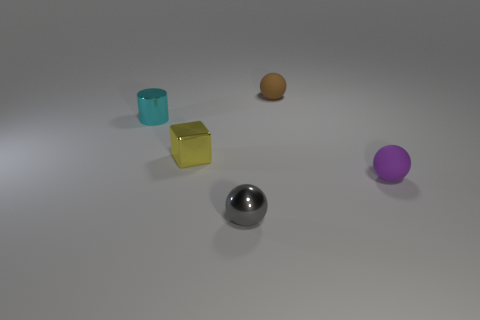Add 1 cyan matte balls. How many objects exist? 6 Subtract all cylinders. How many objects are left? 4 Subtract 0 cyan blocks. How many objects are left? 5 Subtract all gray balls. Subtract all small cubes. How many objects are left? 3 Add 3 metallic blocks. How many metallic blocks are left? 4 Add 2 brown matte things. How many brown matte things exist? 3 